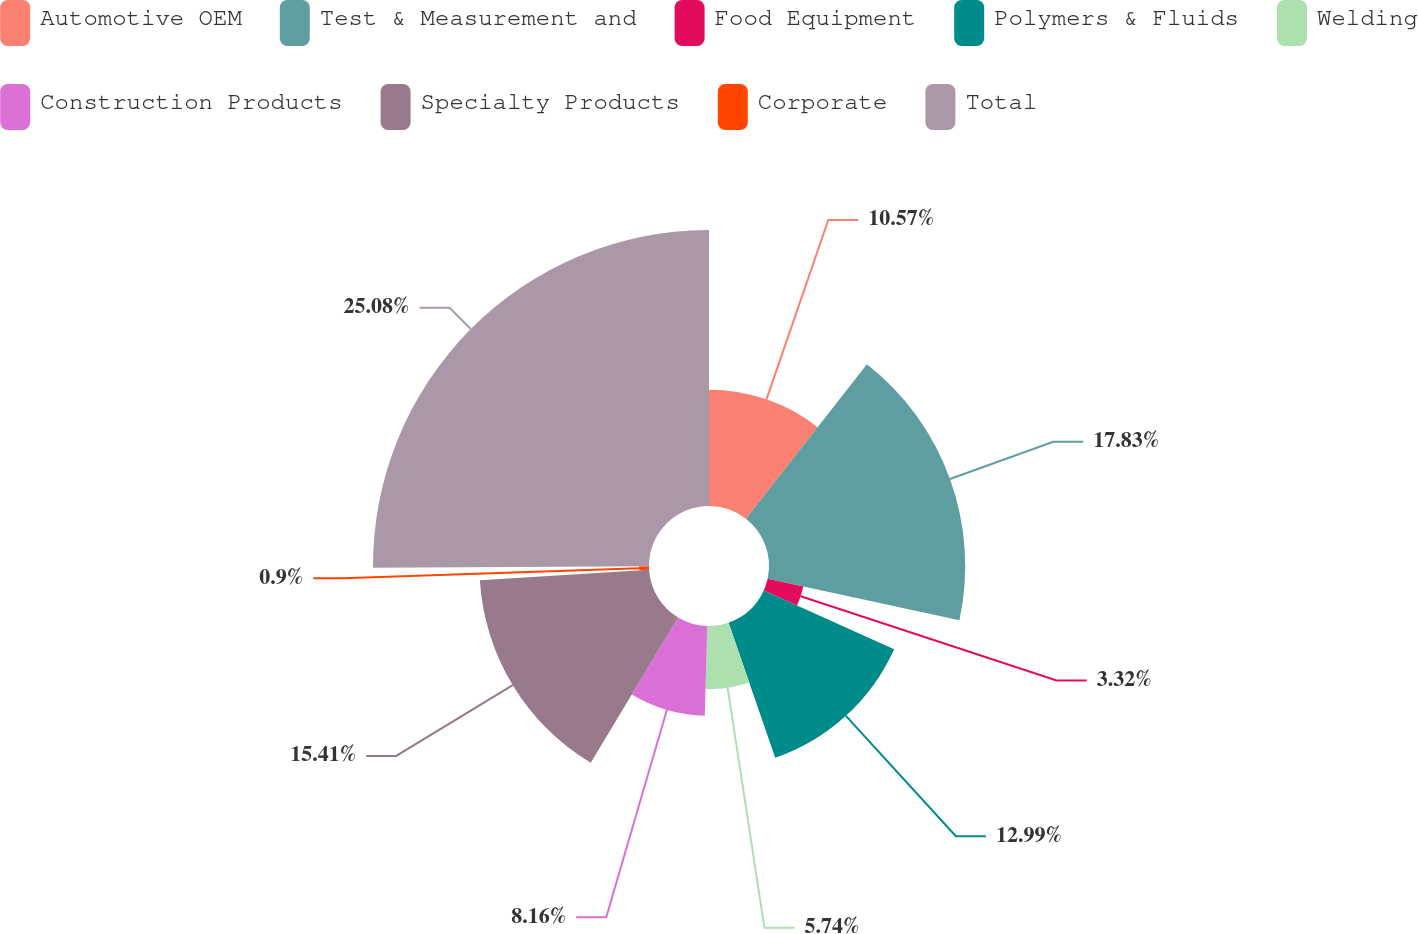Convert chart. <chart><loc_0><loc_0><loc_500><loc_500><pie_chart><fcel>Automotive OEM<fcel>Test & Measurement and<fcel>Food Equipment<fcel>Polymers & Fluids<fcel>Welding<fcel>Construction Products<fcel>Specialty Products<fcel>Corporate<fcel>Total<nl><fcel>10.57%<fcel>17.83%<fcel>3.32%<fcel>12.99%<fcel>5.74%<fcel>8.16%<fcel>15.41%<fcel>0.9%<fcel>25.08%<nl></chart> 